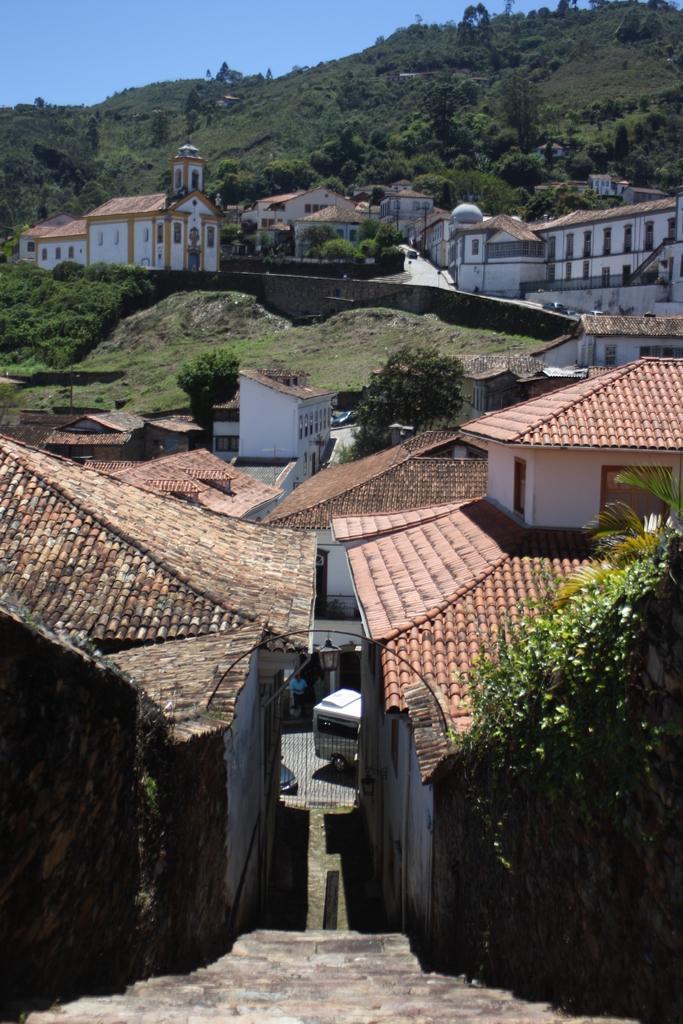Please provide a concise description of this image. In this image I can see few stairs, the roof of few buildings which are brown and black in color and few trees. In the background I can see few buddings, few mountains, few trees on the mountains and the sky. 